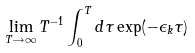<formula> <loc_0><loc_0><loc_500><loc_500>\lim _ { T \rightarrow \infty } T ^ { - 1 } \int _ { 0 } ^ { T } d \tau \exp ( - \epsilon _ { k } \tau )</formula> 